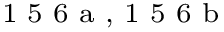Convert formula to latex. <formula><loc_0><loc_0><loc_500><loc_500>^ { 1 } 5 6 a , 1 5 6 b</formula> 